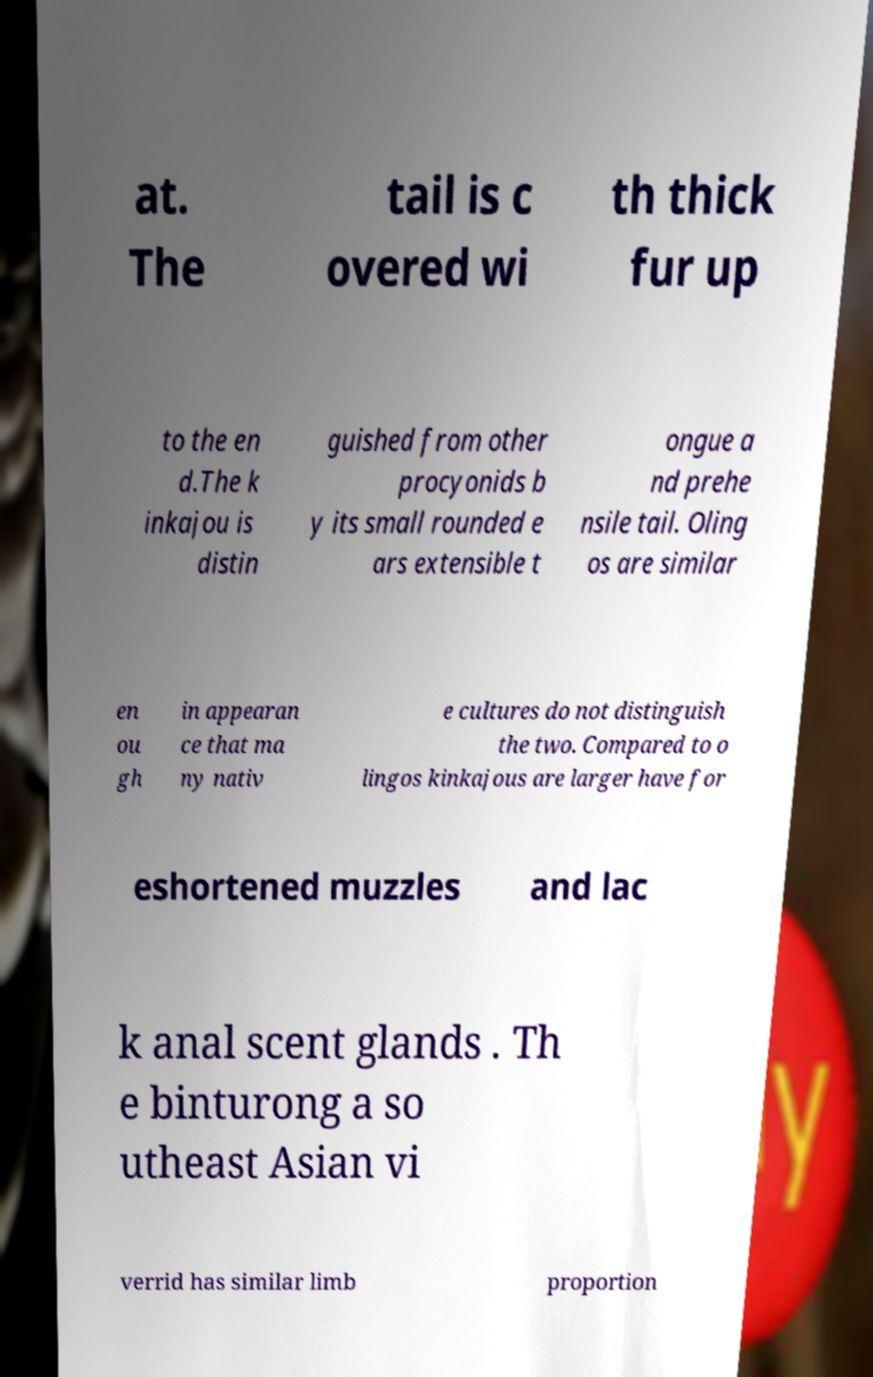Could you extract and type out the text from this image? at. The tail is c overed wi th thick fur up to the en d.The k inkajou is distin guished from other procyonids b y its small rounded e ars extensible t ongue a nd prehe nsile tail. Oling os are similar en ou gh in appearan ce that ma ny nativ e cultures do not distinguish the two. Compared to o lingos kinkajous are larger have for eshortened muzzles and lac k anal scent glands . Th e binturong a so utheast Asian vi verrid has similar limb proportion 